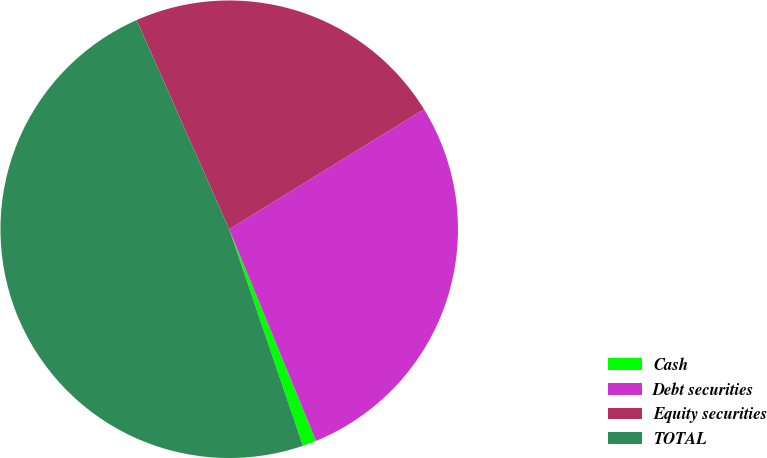Convert chart. <chart><loc_0><loc_0><loc_500><loc_500><pie_chart><fcel>Cash<fcel>Debt securities<fcel>Equity securities<fcel>TOTAL<nl><fcel>0.97%<fcel>27.6%<fcel>22.84%<fcel>48.59%<nl></chart> 